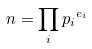<formula> <loc_0><loc_0><loc_500><loc_500>n = \prod _ { i } { p _ { i } } ^ { e _ { i } }</formula> 